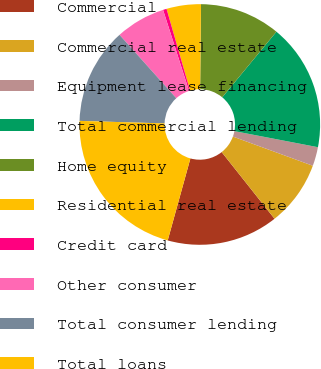Convert chart. <chart><loc_0><loc_0><loc_500><loc_500><pie_chart><fcel>Commercial<fcel>Commercial real estate<fcel>Equipment lease financing<fcel>Total commercial lending<fcel>Home equity<fcel>Residential real estate<fcel>Credit card<fcel>Other consumer<fcel>Total consumer lending<fcel>Total loans<nl><fcel>14.97%<fcel>8.76%<fcel>2.55%<fcel>17.04%<fcel>10.83%<fcel>4.62%<fcel>0.48%<fcel>6.69%<fcel>12.9%<fcel>21.18%<nl></chart> 